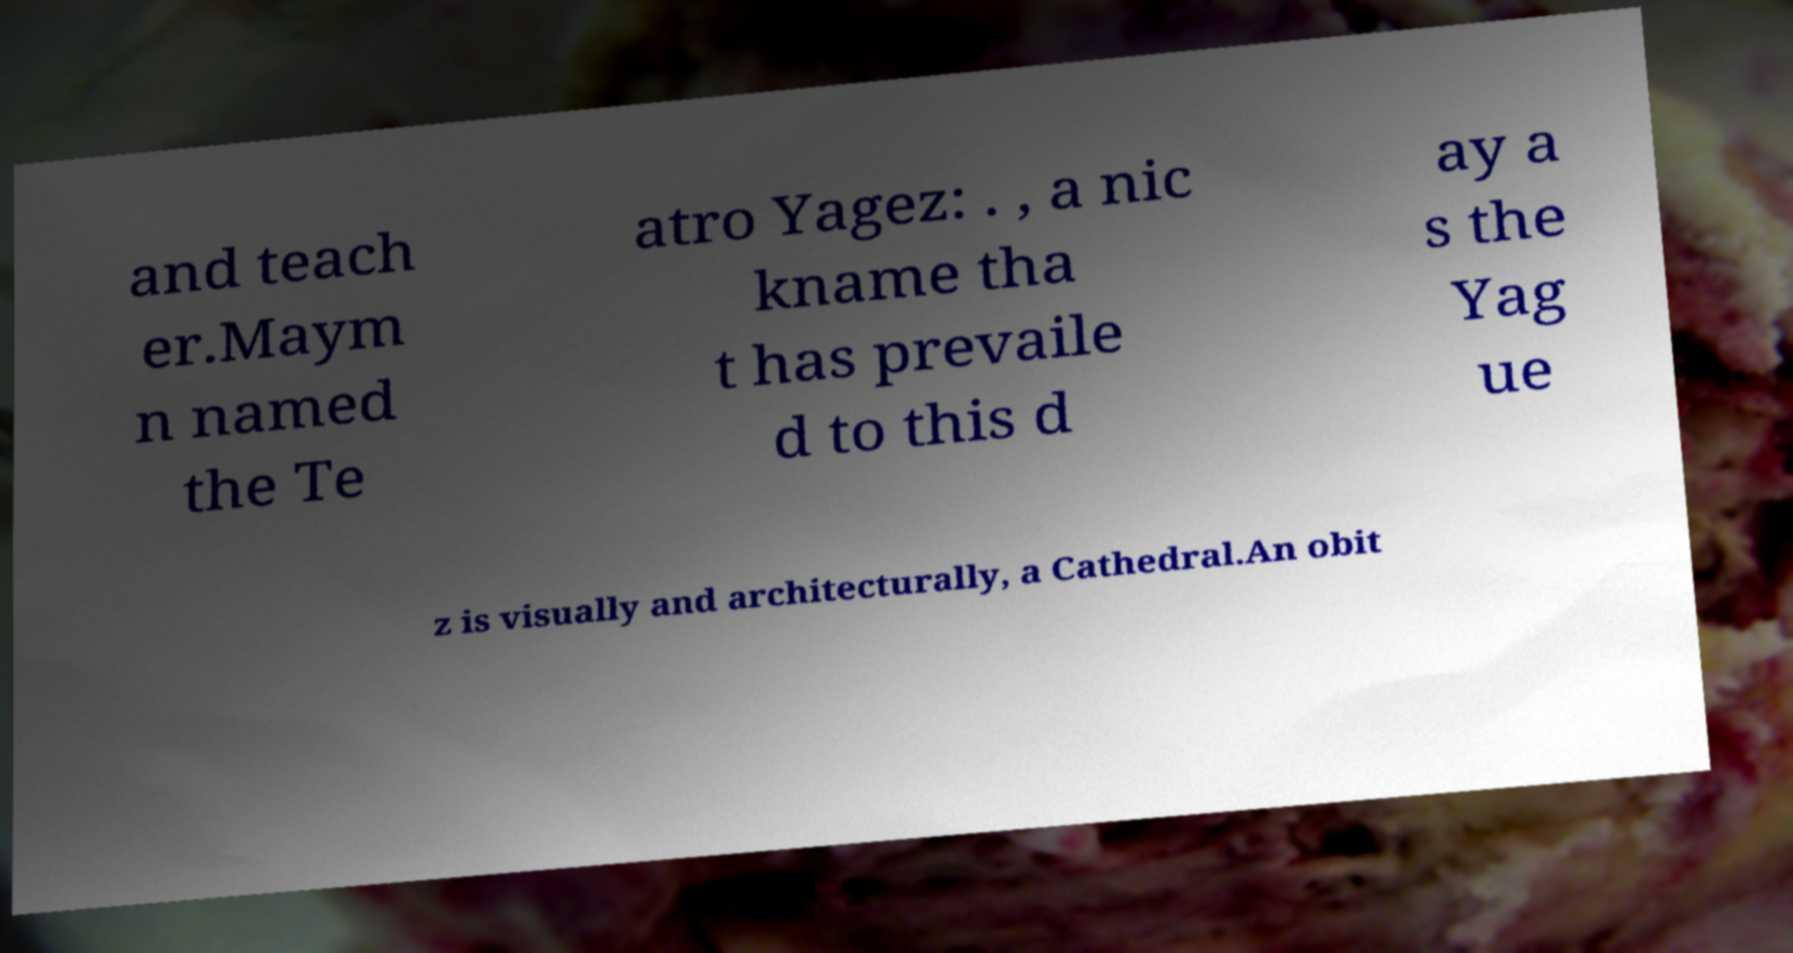Please read and relay the text visible in this image. What does it say? and teach er.Maym n named the Te atro Yagez: . , a nic kname tha t has prevaile d to this d ay a s the Yag ue z is visually and architecturally, a Cathedral.An obit 